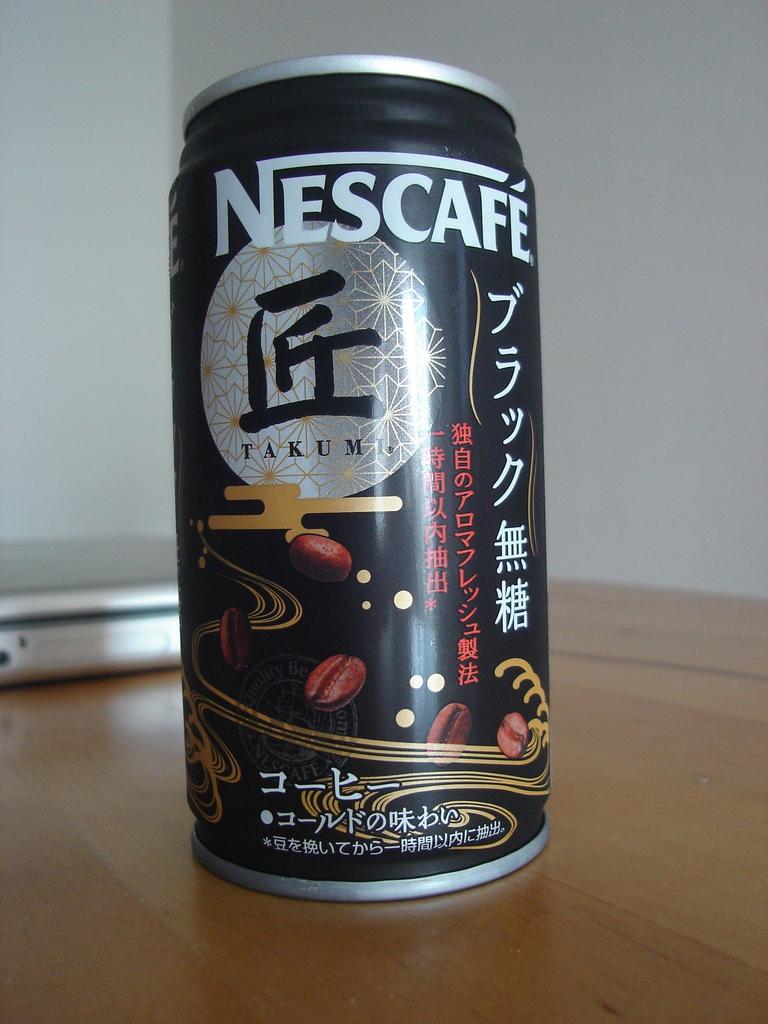What brand of drink is in this can?
Provide a succinct answer. Nescafe. 